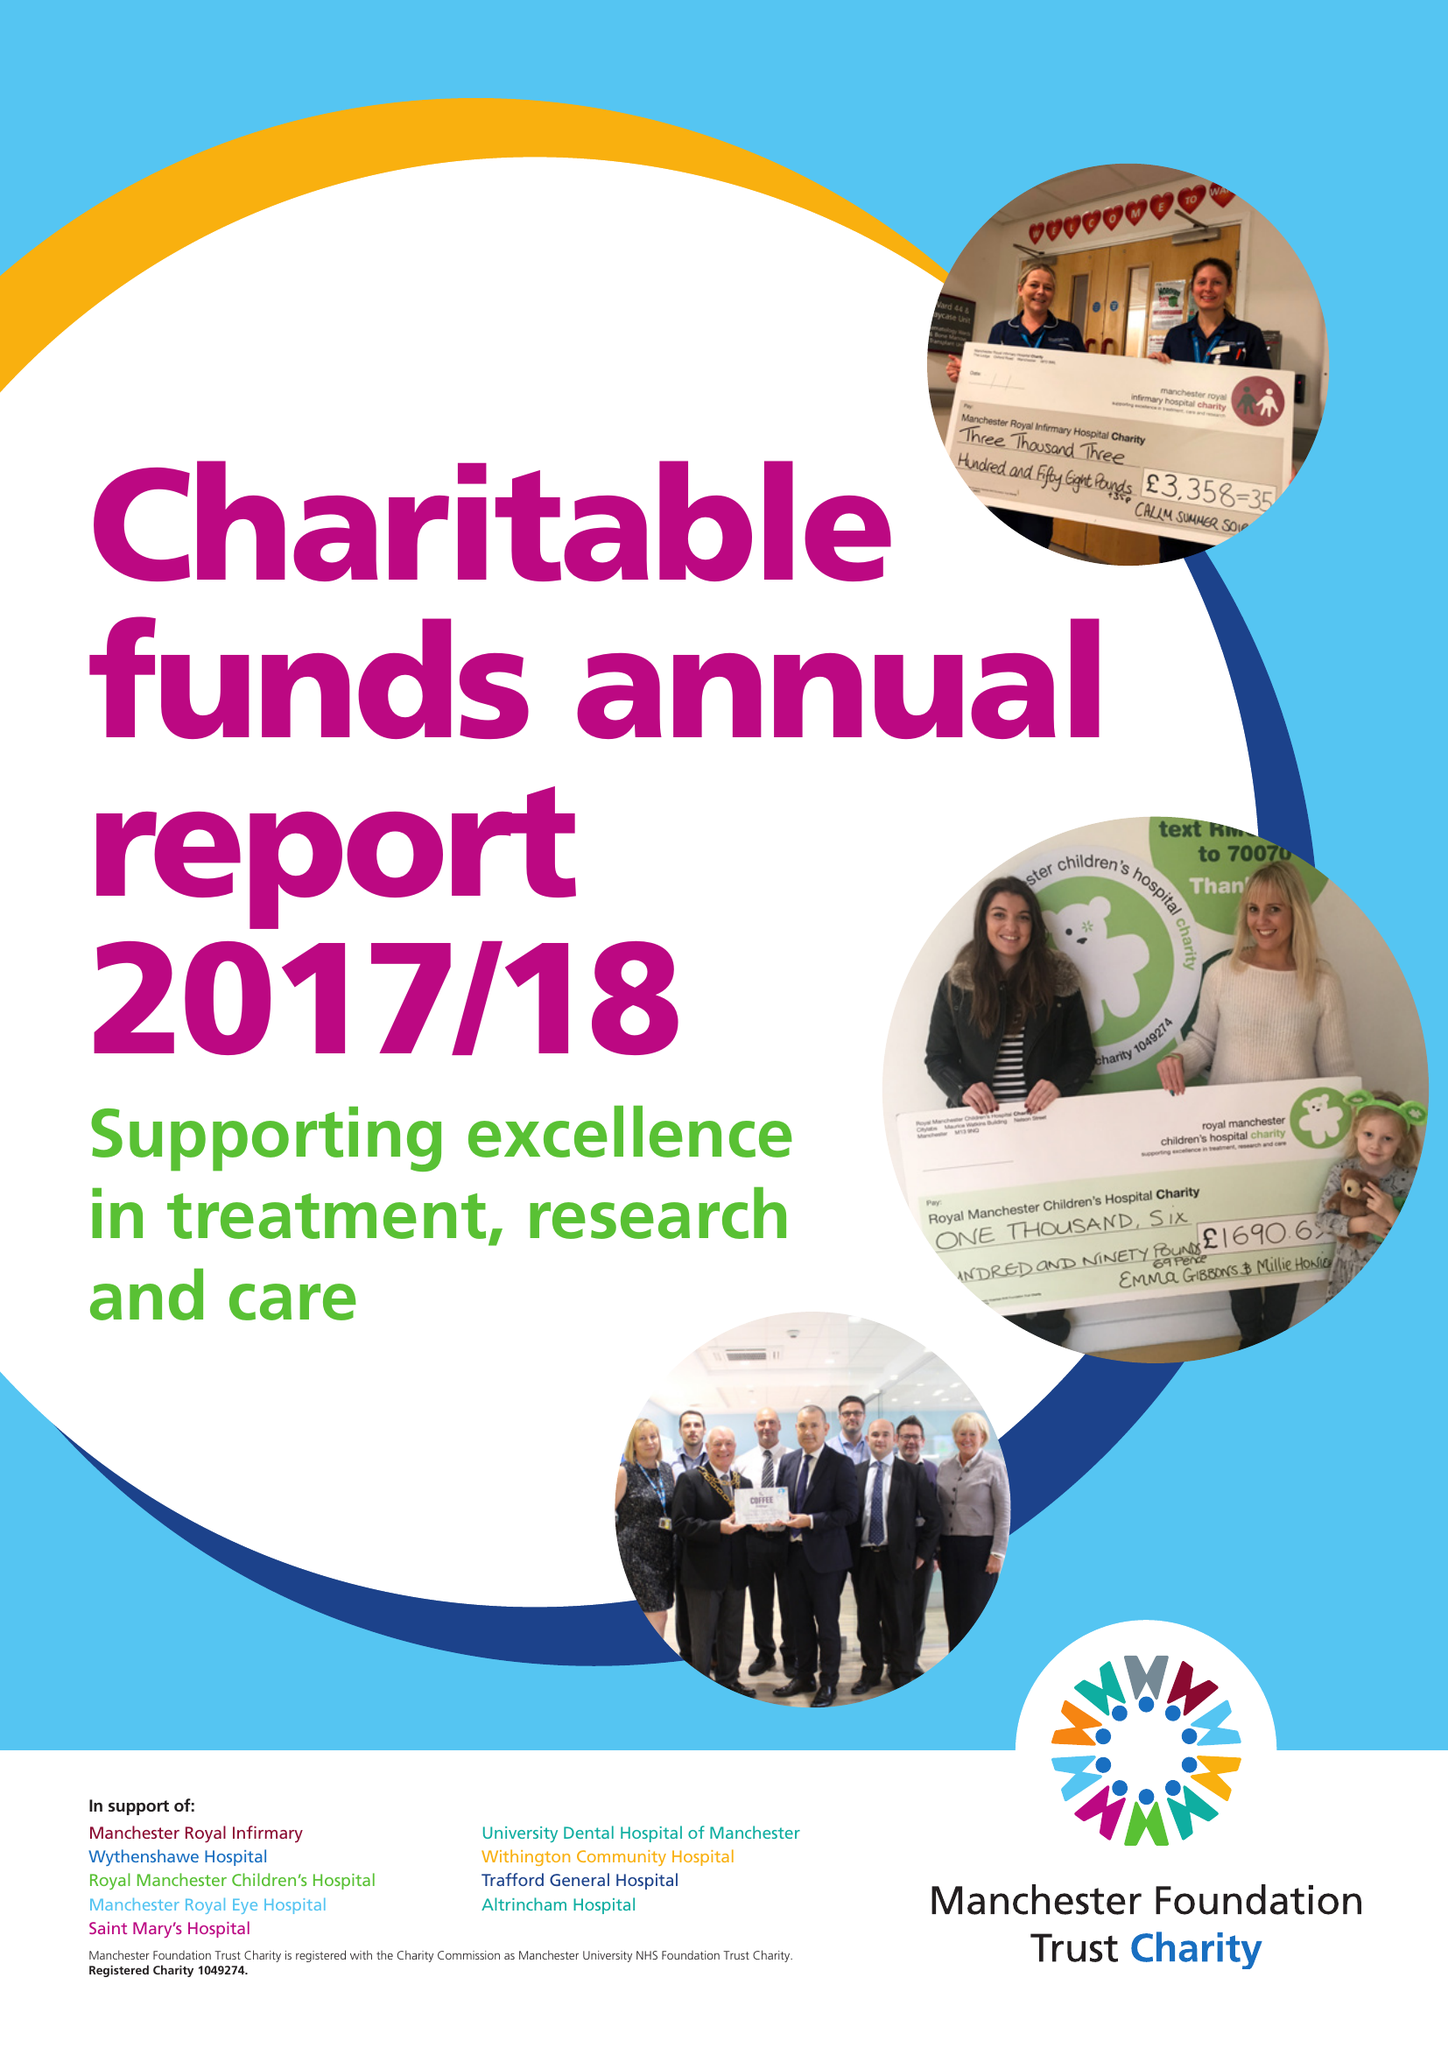What is the value for the spending_annually_in_british_pounds?
Answer the question using a single word or phrase. 9535000.00 